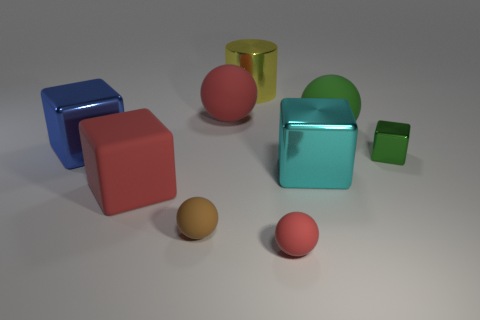Subtract 1 cubes. How many cubes are left? 3 Subtract all balls. How many objects are left? 5 Add 1 large red blocks. How many large red blocks exist? 2 Subtract 0 gray spheres. How many objects are left? 9 Subtract all large blue rubber cylinders. Subtract all tiny red balls. How many objects are left? 8 Add 4 green metal objects. How many green metal objects are left? 5 